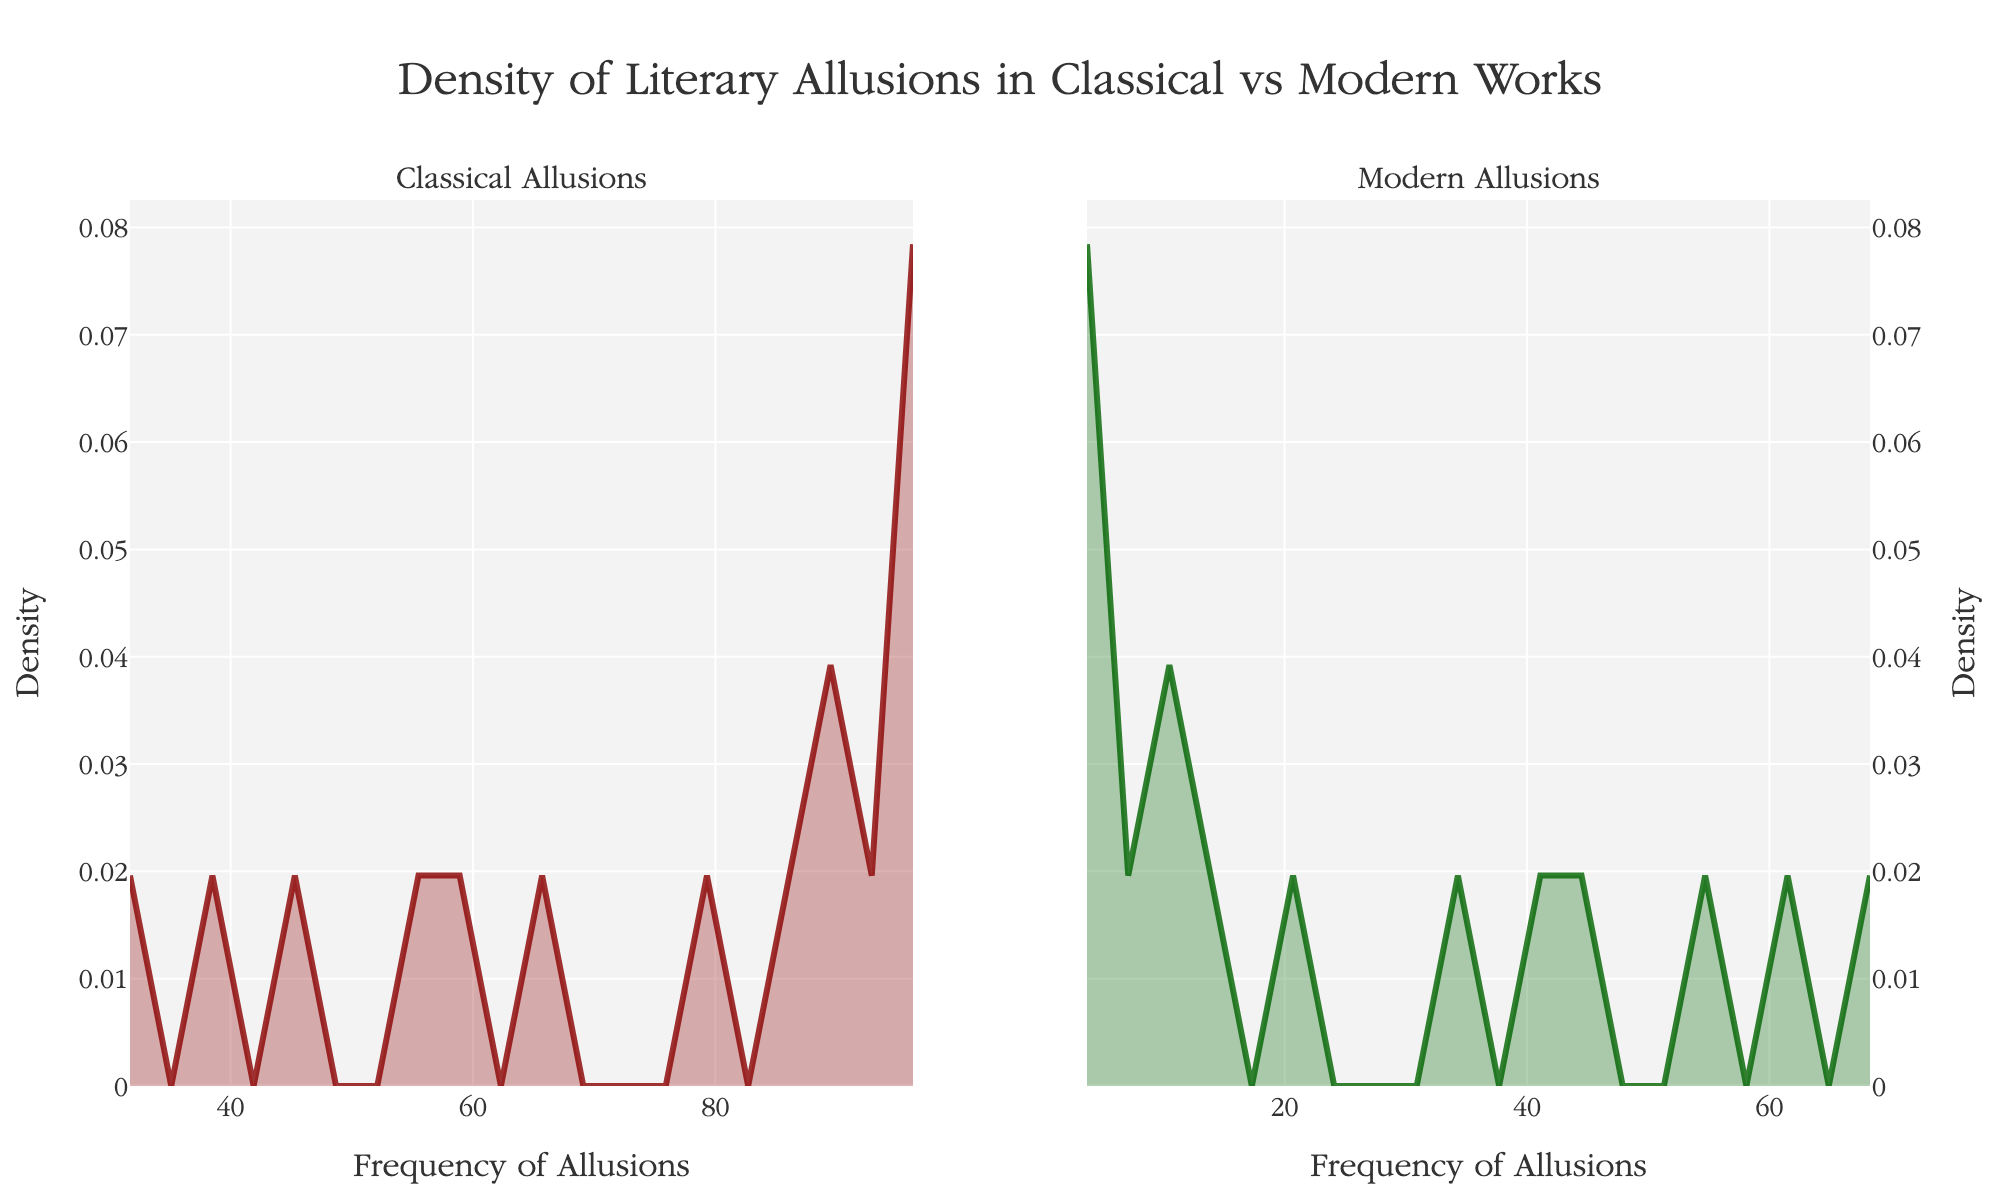What is the title of the plot? The title is written at the top center of the figure, which reads "Density of Literary Allusions in Classical vs Modern Works".
Answer: Density of Literary Allusions in Classical vs Modern Works What are the x-axis labels in the subplots? Both x-axes on the subplots have the label "Frequency of Allusions". This can be seen at the bottom of both the left and right subplots.
Answer: Frequency of Allusions Which color represents the density of classical allusions in the plot? In the left subplot, the classical allusions are represented by a shade of dark red. This is indicated by the fill and line colors.
Answer: Dark red Which subplot shows a higher peak density value and for which kind of allusions? By comparing the peak heights of the density curves, it can be seen that the left subplot, which represents classical allusions, has a higher peak density value.
Answer: Classical allusions Based on the figure, which kind of allusion has a more spread-out density distribution? The right subplot representing modern allusions shows a wider spread in its density distribution as compared to the classical allusions on the left subplot.
Answer: Modern allusions Can you identify a specific frequency where classical allusions are dense but modern ones are not? The left subplot demonstrates a heavy peak around the frequency of 90 for classical allusions, while the right subplot shows no significant corresponding density at this frequency for modern allusions.
Answer: Around 90 Is the density distribution for modern allusions more concentrated towards lower frequencies or higher frequencies compared to classical allusions? Observing the density plots, it is evident that modern allusions have a higher density concentration towards lower frequencies compared to classical allusions, which are more concentrated towards higher frequencies.
Answer: Lower frequencies How does the frequency distribution in modern allusions compare with that of classical allusions at the lower end of the range? The subplot for modern allusions shows higher densities in the lower frequency range (between 0 to 50), while classical allusions show lower densities in this range.
Answer: Modern allusions are higher Estimate the range of frequencies for which the density of classical allusions is greater than that of modern allusions. By comparing the density plots, one can see that for frequencies higher than approximately 55, the density of classical allusions remains greater than that of modern allusions.
Answer: Greater than approximately 55 Do any of the subplots show a density distribution that suggests a bimodal pattern? Neither of the subplots for classical or modern allusions exhibits a clear bimodal pattern as both show a single, main peak.
Answer: No 